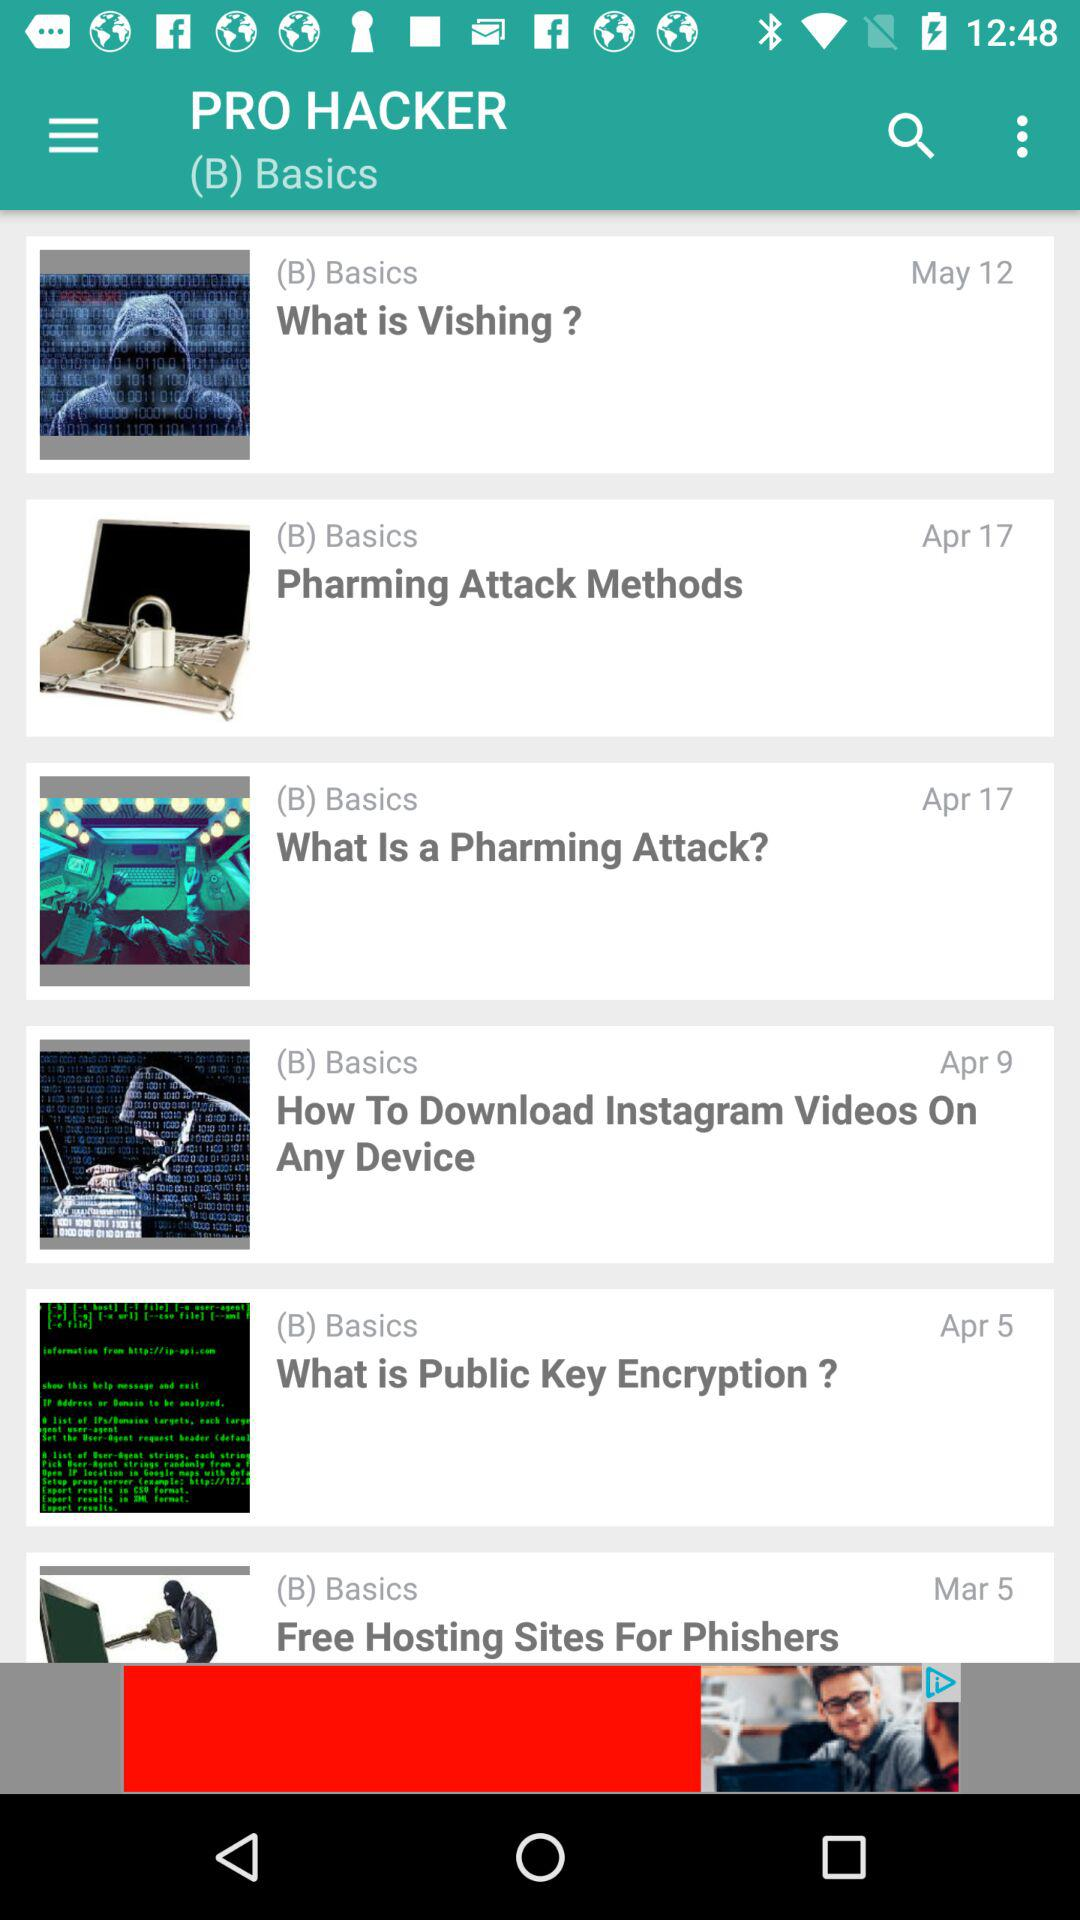What is the mentioned date for "What is Vishing?"? The mentioned date for "What is Vishing?" is May 12. 